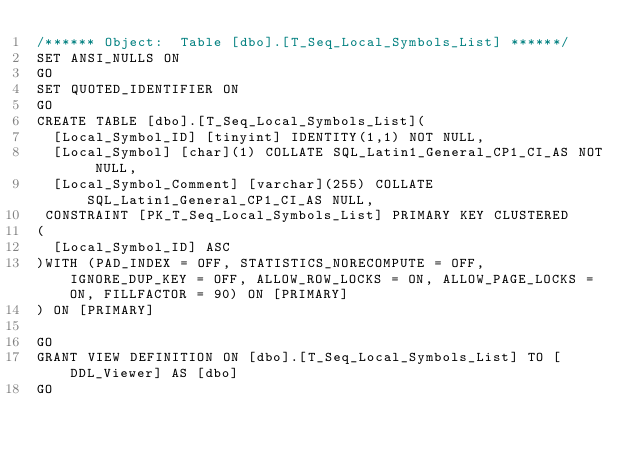Convert code to text. <code><loc_0><loc_0><loc_500><loc_500><_SQL_>/****** Object:  Table [dbo].[T_Seq_Local_Symbols_List] ******/
SET ANSI_NULLS ON
GO
SET QUOTED_IDENTIFIER ON
GO
CREATE TABLE [dbo].[T_Seq_Local_Symbols_List](
	[Local_Symbol_ID] [tinyint] IDENTITY(1,1) NOT NULL,
	[Local_Symbol] [char](1) COLLATE SQL_Latin1_General_CP1_CI_AS NOT NULL,
	[Local_Symbol_Comment] [varchar](255) COLLATE SQL_Latin1_General_CP1_CI_AS NULL,
 CONSTRAINT [PK_T_Seq_Local_Symbols_List] PRIMARY KEY CLUSTERED 
(
	[Local_Symbol_ID] ASC
)WITH (PAD_INDEX = OFF, STATISTICS_NORECOMPUTE = OFF, IGNORE_DUP_KEY = OFF, ALLOW_ROW_LOCKS = ON, ALLOW_PAGE_LOCKS = ON, FILLFACTOR = 90) ON [PRIMARY]
) ON [PRIMARY]

GO
GRANT VIEW DEFINITION ON [dbo].[T_Seq_Local_Symbols_List] TO [DDL_Viewer] AS [dbo]
GO
</code> 